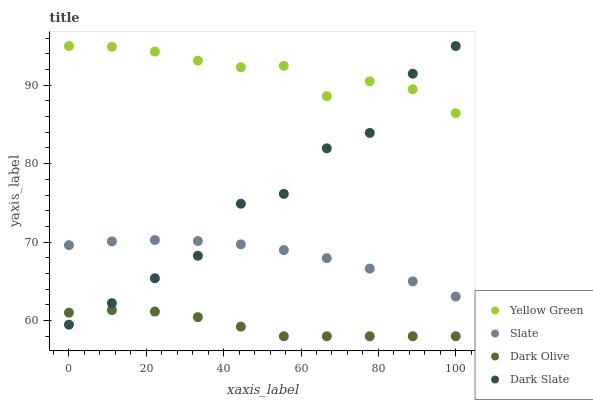Does Dark Olive have the minimum area under the curve?
Answer yes or no. Yes. Does Yellow Green have the maximum area under the curve?
Answer yes or no. Yes. Does Slate have the minimum area under the curve?
Answer yes or no. No. Does Slate have the maximum area under the curve?
Answer yes or no. No. Is Slate the smoothest?
Answer yes or no. Yes. Is Dark Slate the roughest?
Answer yes or no. Yes. Is Dark Olive the smoothest?
Answer yes or no. No. Is Dark Olive the roughest?
Answer yes or no. No. Does Dark Olive have the lowest value?
Answer yes or no. Yes. Does Slate have the lowest value?
Answer yes or no. No. Does Yellow Green have the highest value?
Answer yes or no. Yes. Does Slate have the highest value?
Answer yes or no. No. Is Dark Olive less than Slate?
Answer yes or no. Yes. Is Yellow Green greater than Dark Olive?
Answer yes or no. Yes. Does Slate intersect Dark Slate?
Answer yes or no. Yes. Is Slate less than Dark Slate?
Answer yes or no. No. Is Slate greater than Dark Slate?
Answer yes or no. No. Does Dark Olive intersect Slate?
Answer yes or no. No. 